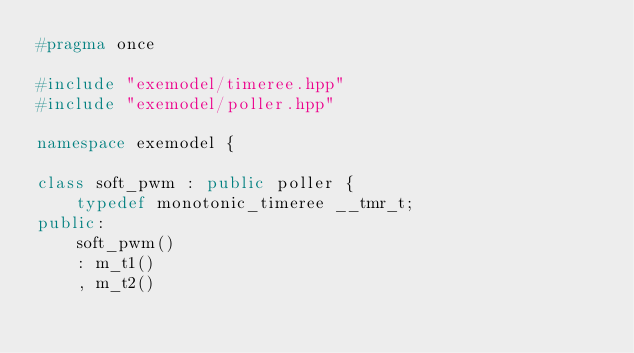<code> <loc_0><loc_0><loc_500><loc_500><_C++_>#pragma once

#include "exemodel/timeree.hpp"
#include "exemodel/poller.hpp"

namespace exemodel {

class soft_pwm : public poller {
	typedef monotonic_timeree __tmr_t;
public:
	soft_pwm()
	: m_t1()
	, m_t2()</code> 